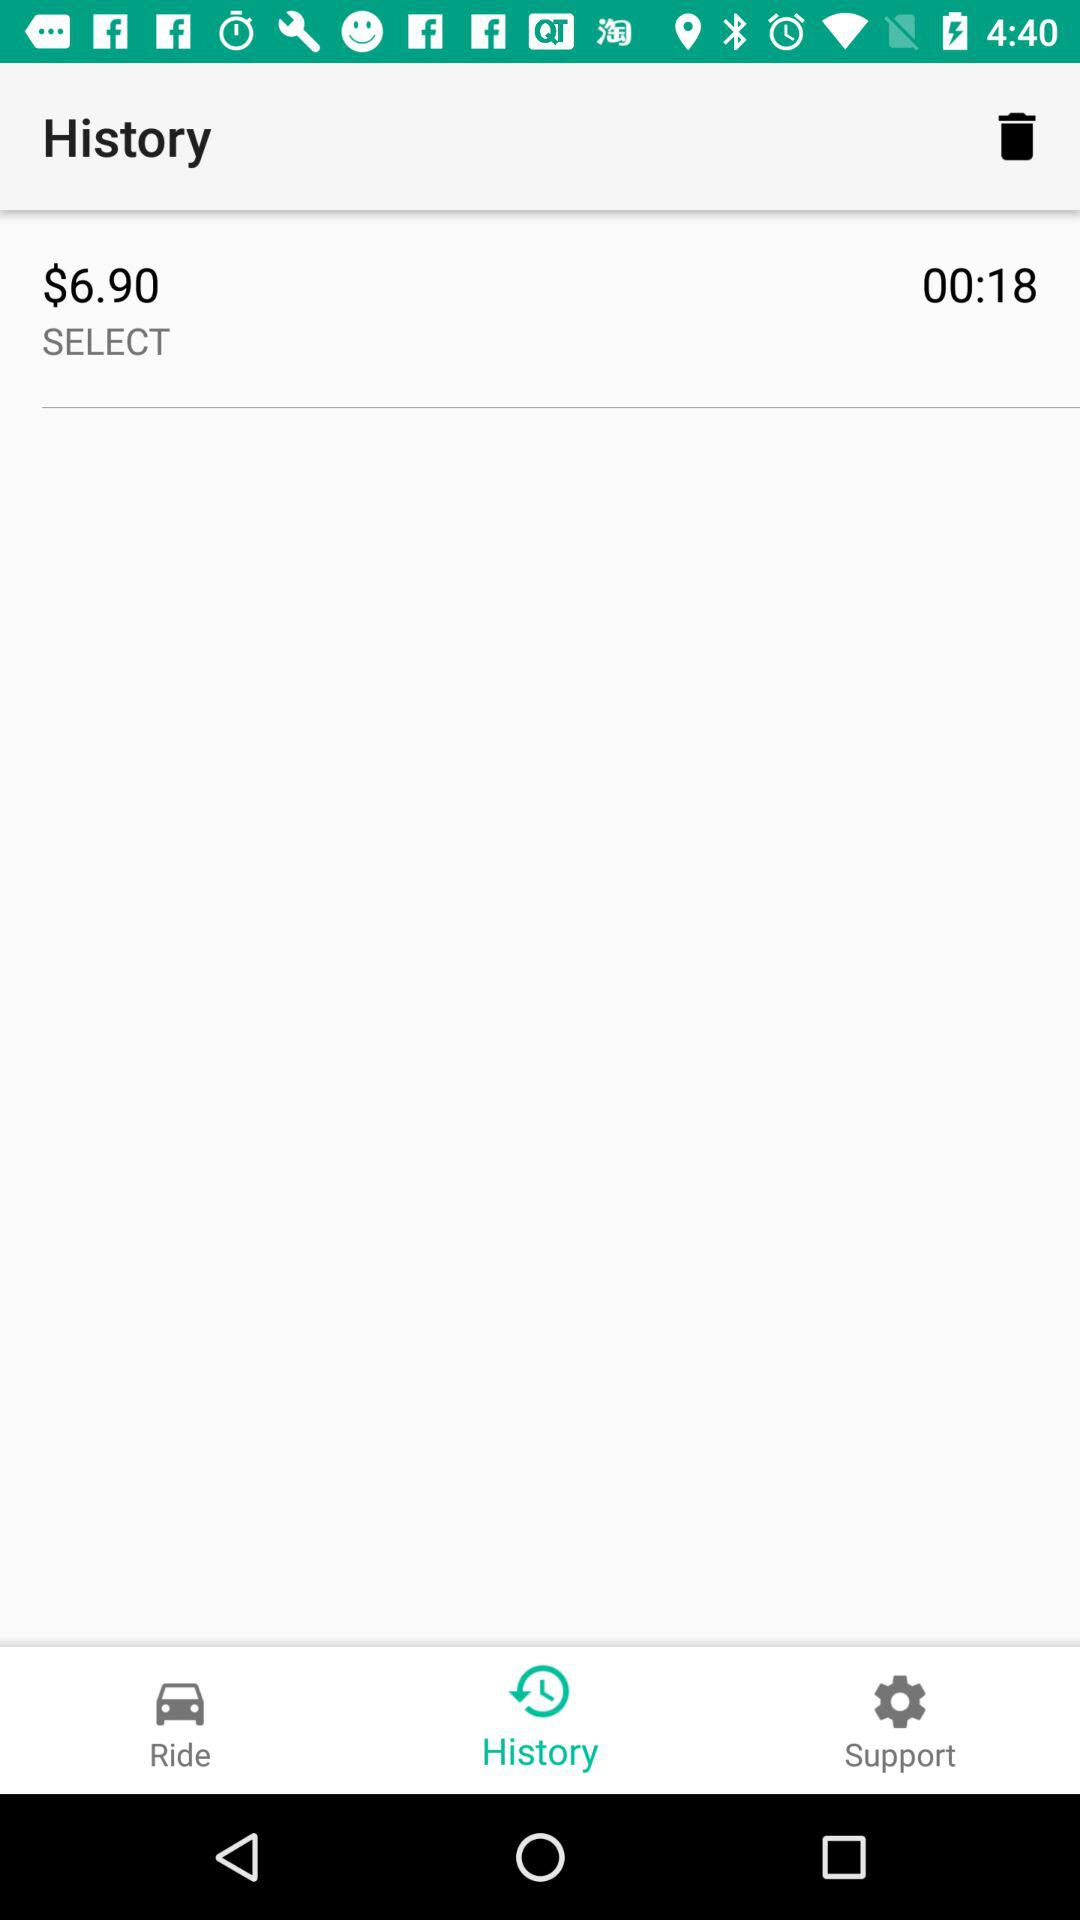Which tab is selected? The selected tab is History. 